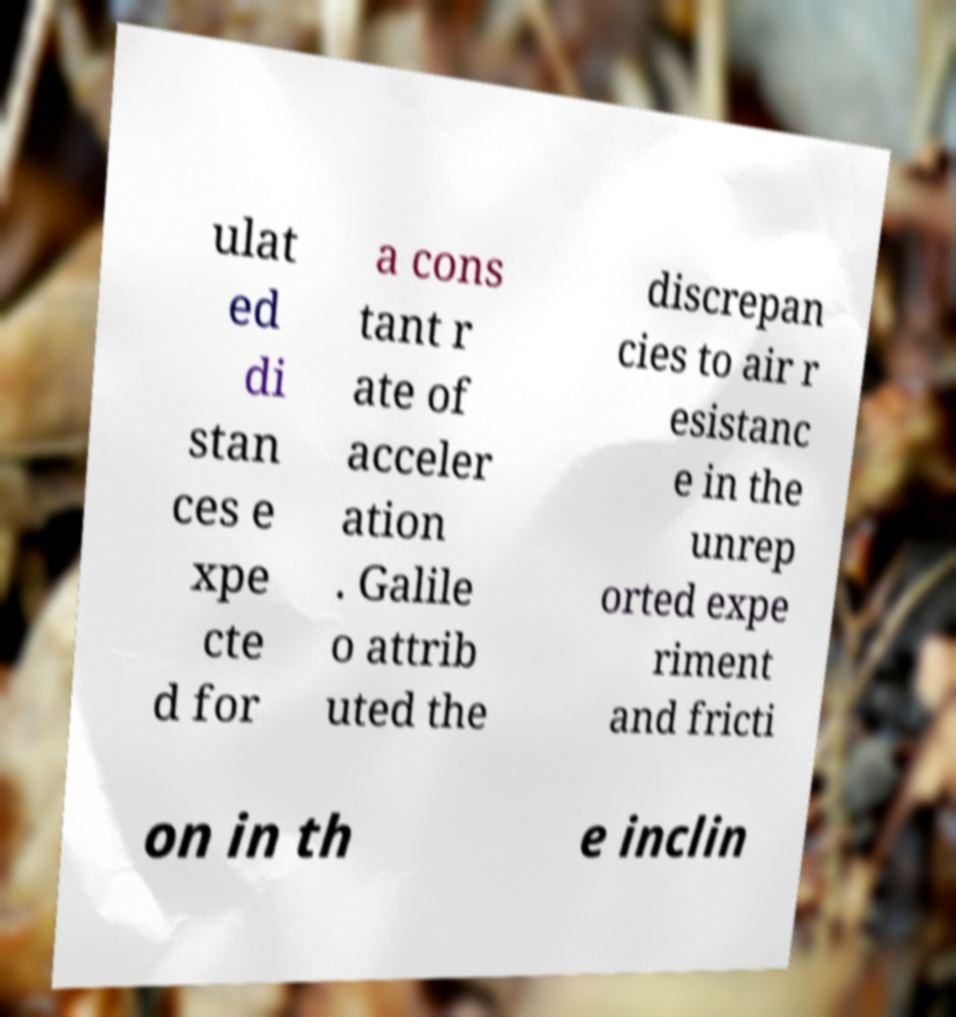Please read and relay the text visible in this image. What does it say? ulat ed di stan ces e xpe cte d for a cons tant r ate of acceler ation . Galile o attrib uted the discrepan cies to air r esistanc e in the unrep orted expe riment and fricti on in th e inclin 